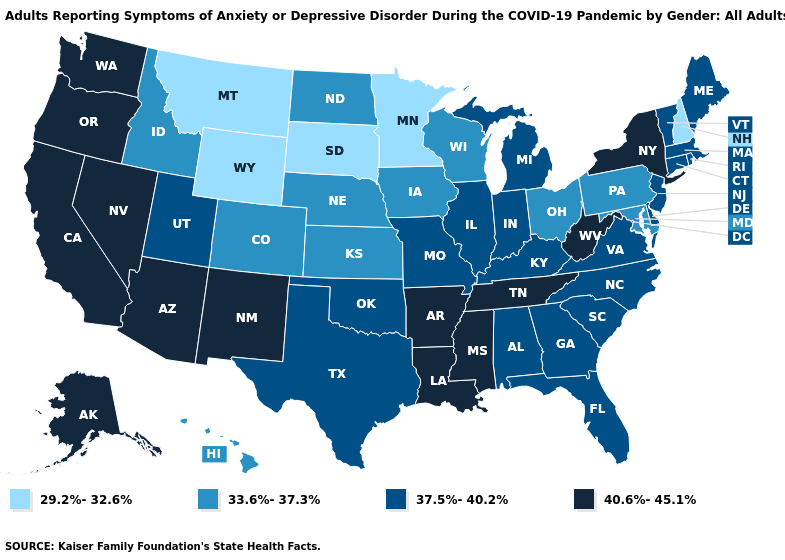Does West Virginia have a lower value than Kansas?
Write a very short answer. No. What is the value of Louisiana?
Give a very brief answer. 40.6%-45.1%. What is the value of Washington?
Give a very brief answer. 40.6%-45.1%. What is the highest value in the MidWest ?
Be succinct. 37.5%-40.2%. What is the value of Vermont?
Concise answer only. 37.5%-40.2%. What is the value of Kansas?
Concise answer only. 33.6%-37.3%. Name the states that have a value in the range 29.2%-32.6%?
Quick response, please. Minnesota, Montana, New Hampshire, South Dakota, Wyoming. How many symbols are there in the legend?
Quick response, please. 4. Does North Dakota have a higher value than Oklahoma?
Short answer required. No. Does the map have missing data?
Answer briefly. No. What is the value of Colorado?
Concise answer only. 33.6%-37.3%. What is the value of Massachusetts?
Keep it brief. 37.5%-40.2%. What is the highest value in the USA?
Quick response, please. 40.6%-45.1%. Is the legend a continuous bar?
Give a very brief answer. No. Name the states that have a value in the range 29.2%-32.6%?
Be succinct. Minnesota, Montana, New Hampshire, South Dakota, Wyoming. 